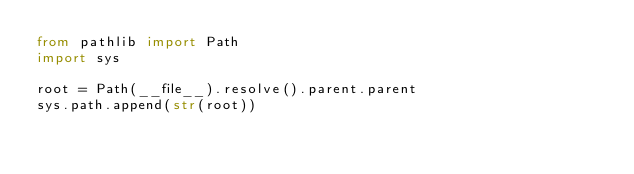<code> <loc_0><loc_0><loc_500><loc_500><_Python_>from pathlib import Path
import sys

root = Path(__file__).resolve().parent.parent
sys.path.append(str(root))
</code> 